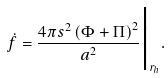<formula> <loc_0><loc_0><loc_500><loc_500>\dot { f } = \frac { 4 \pi s ^ { 2 } \left ( \Phi + \Pi \right ) ^ { 2 } } { a ^ { 2 } } \Big | _ { r _ { h } } .</formula> 